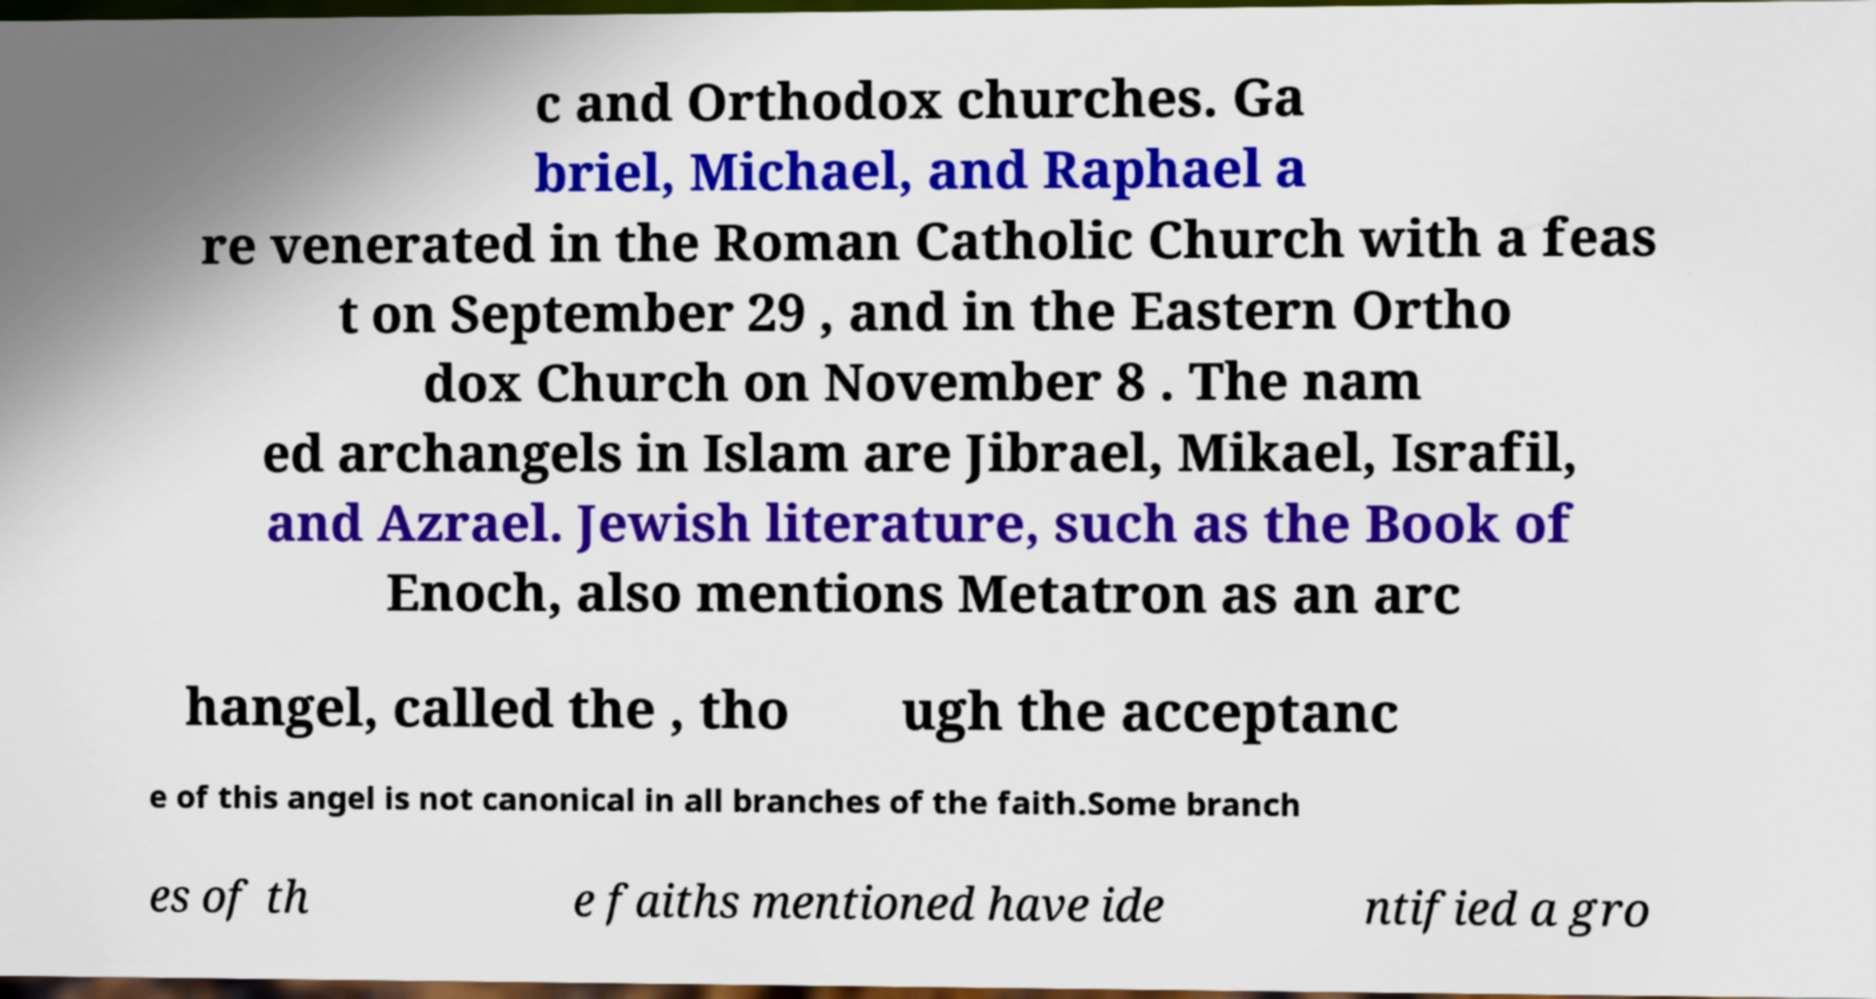Can you accurately transcribe the text from the provided image for me? c and Orthodox churches. Ga briel, Michael, and Raphael a re venerated in the Roman Catholic Church with a feas t on September 29 , and in the Eastern Ortho dox Church on November 8 . The nam ed archangels in Islam are Jibrael, Mikael, Israfil, and Azrael. Jewish literature, such as the Book of Enoch, also mentions Metatron as an arc hangel, called the , tho ugh the acceptanc e of this angel is not canonical in all branches of the faith.Some branch es of th e faiths mentioned have ide ntified a gro 